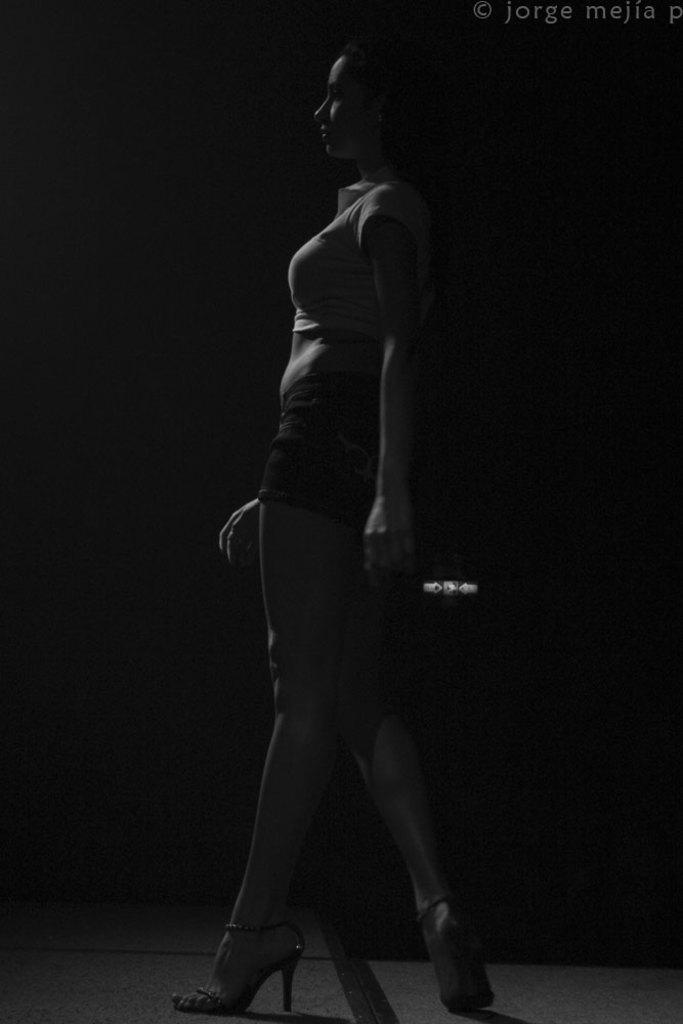Who is the main subject in the image? There is a woman in the image. What is the woman's position in the image? The woman is standing in the front. What can be observed about the background of the image? The background of the image is dark. What type of train can be seen in the background of the image? There is no train present in the image; the background is dark. How does the woman wash her hands in the image? There is no indication of the woman washing her hands in the image. 